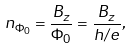Convert formula to latex. <formula><loc_0><loc_0><loc_500><loc_500>n _ { \Phi _ { 0 } } = \frac { B _ { z } } { \Phi _ { 0 } } = \frac { B _ { z } } { h / e } ,</formula> 